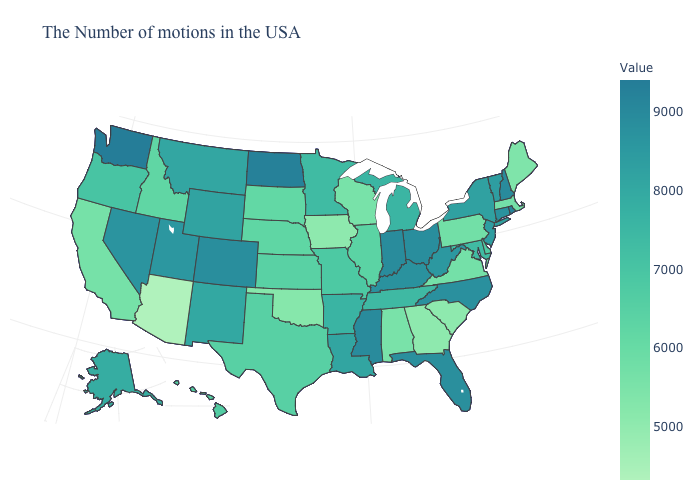Which states have the highest value in the USA?
Concise answer only. Washington. Does Mississippi have the highest value in the South?
Quick response, please. Yes. Which states hav the highest value in the Northeast?
Answer briefly. Rhode Island. Does Oklahoma have the highest value in the USA?
Answer briefly. No. Is the legend a continuous bar?
Answer briefly. Yes. Which states have the lowest value in the Northeast?
Answer briefly. Maine. 